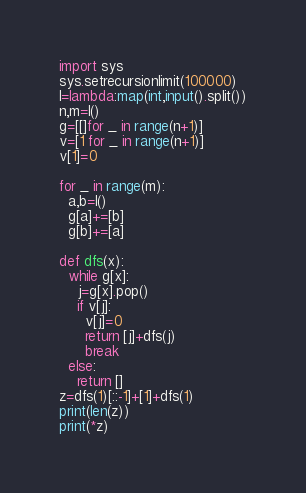<code> <loc_0><loc_0><loc_500><loc_500><_Python_>import sys
sys.setrecursionlimit(100000)
I=lambda:map(int,input().split())
n,m=I()
g=[[]for _ in range(n+1)]
v=[1 for _ in range(n+1)]
v[1]=0

for _ in range(m):
  a,b=I()
  g[a]+=[b]
  g[b]+=[a]

def dfs(x):
  while g[x]:
    j=g[x].pop()
    if v[j]:
      v[j]=0
      return [j]+dfs(j)
      break
  else:
    return []
z=dfs(1)[::-1]+[1]+dfs(1)
print(len(z))
print(*z)</code> 